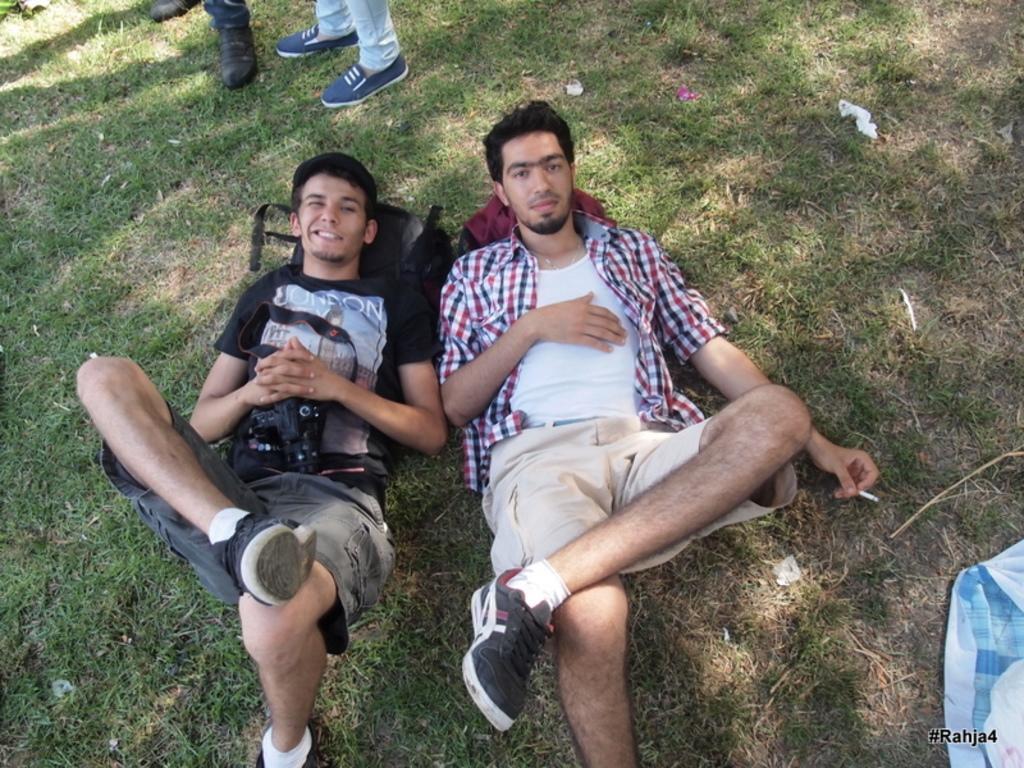Can you describe this image briefly? In this picture I can see there are two persons lying on the floor and they are holding cigarette in the hand. In the backdrop I can see there are two people standing. 